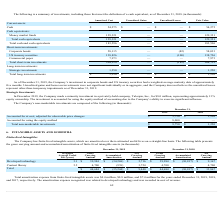According to Cornerstone Ondemand's financial document, As of December 31, 2019, how long was the weighted-average maturity date of the Company's investment in corporate bonds and US treasury securities? approximately five months.. The document states: "securities had a weighted-average maturity date of approximately five months. Unrealized gains and losses on investments were not significant individu..." Also, What was the total amortized cost of money market funds? According to the financial document, 129,321 (in thousands). The relevant text states: "Money market funds 129,321 — — 129,321..." Also, What was the total amortized cost of corporate bonds? According to the financial document, 58,115 (in thousands). The relevant text states: "Corporate bonds 58,115 — (82) 58,033..." Also, can you calculate: What was the sum of amortized cost of corporate bonds and US treasury securities? Based on the calculation: 58,115+138,826, the result is 196941 (in thousands). This is based on the information: "US treasury securities 138,826 — (100) 138,726 Corporate bonds 58,115 — (82) 58,033..." The key data points involved are: 138,826, 58,115. Also, can you calculate: What percentage of total fair value of cash and cash equivalents consists of cash? Based on the calculation: (54,275/183,596), the result is 29.56 (percentage). This is based on the information: "Total cash and cash equivalents 183,596 — — 183,596 Cash $ 54,275 $ — $ — $ 54,275..." The key data points involved are: 183,596, 54,275. Also, can you calculate: What percentage of total unrealized losses for short-term investments consist of corporate bonds? Based on the calculation: (82/182), the result is 45.05 (percentage). This is based on the information: "Total short-term investments 204,914 — (182) 204,732 Total short-term investments 204,914 — (182) 204,732..." The key data points involved are: 182, 82. 